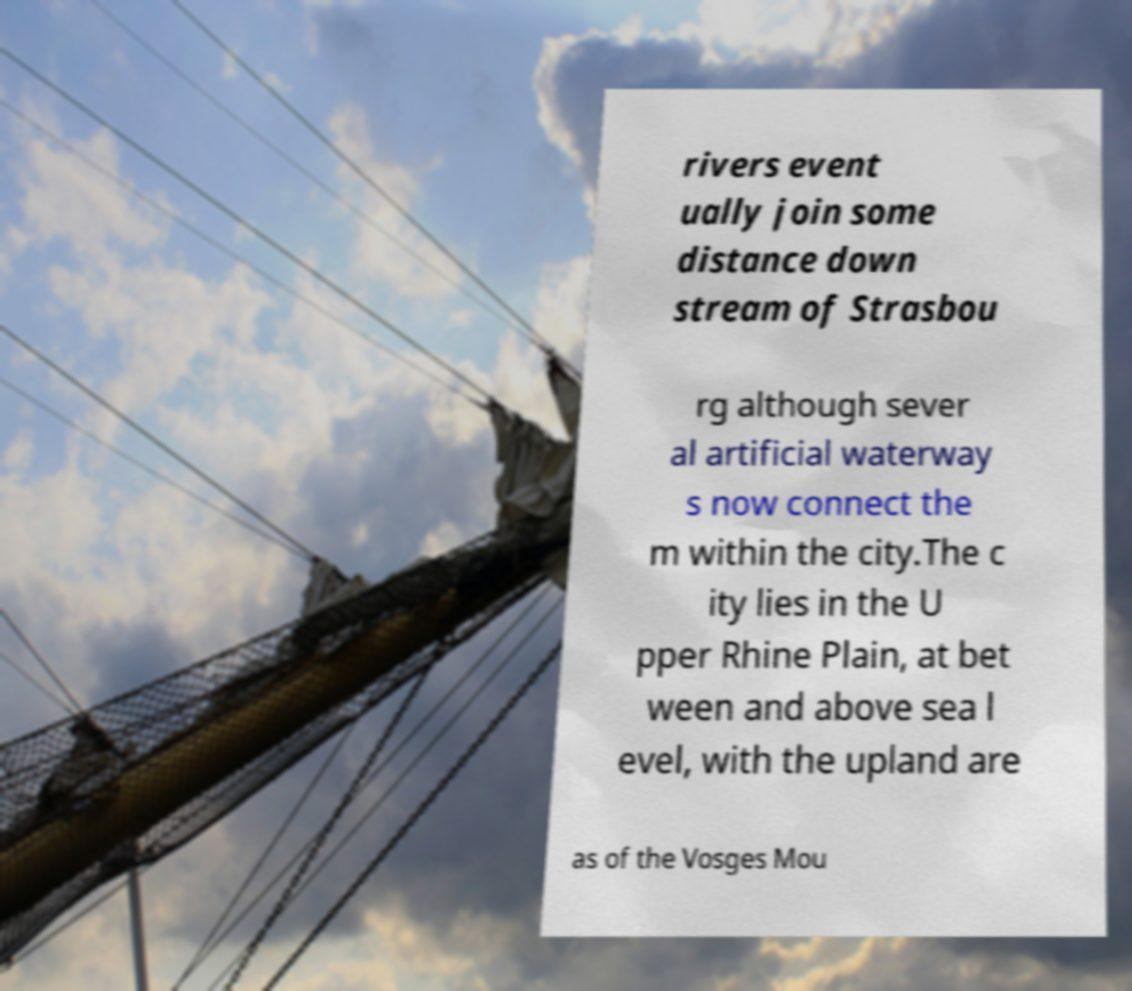Could you extract and type out the text from this image? rivers event ually join some distance down stream of Strasbou rg although sever al artificial waterway s now connect the m within the city.The c ity lies in the U pper Rhine Plain, at bet ween and above sea l evel, with the upland are as of the Vosges Mou 